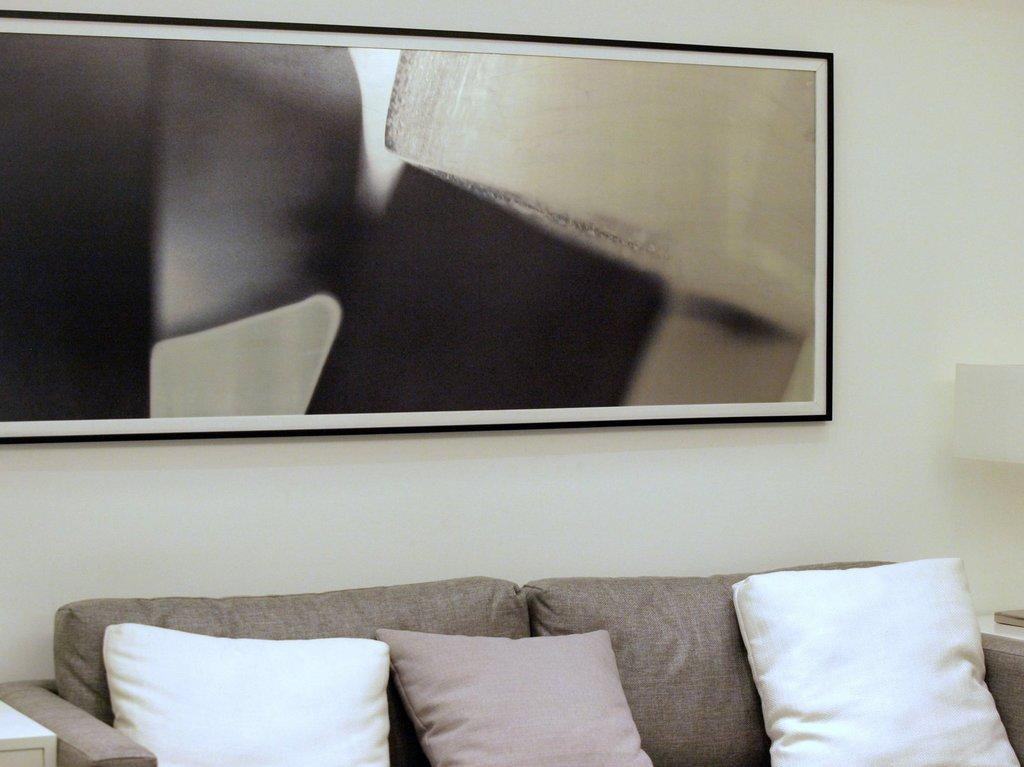What type of furniture is present in the image? There is a sofa in the image. What is on the sofa? There are cushions on the sofa. What can be seen on the wall in the image? There is a frame on the wall. How many bubbles are floating around the frame on the wall? There are no bubbles present in the image; only the sofa, cushions, and frame are visible. 